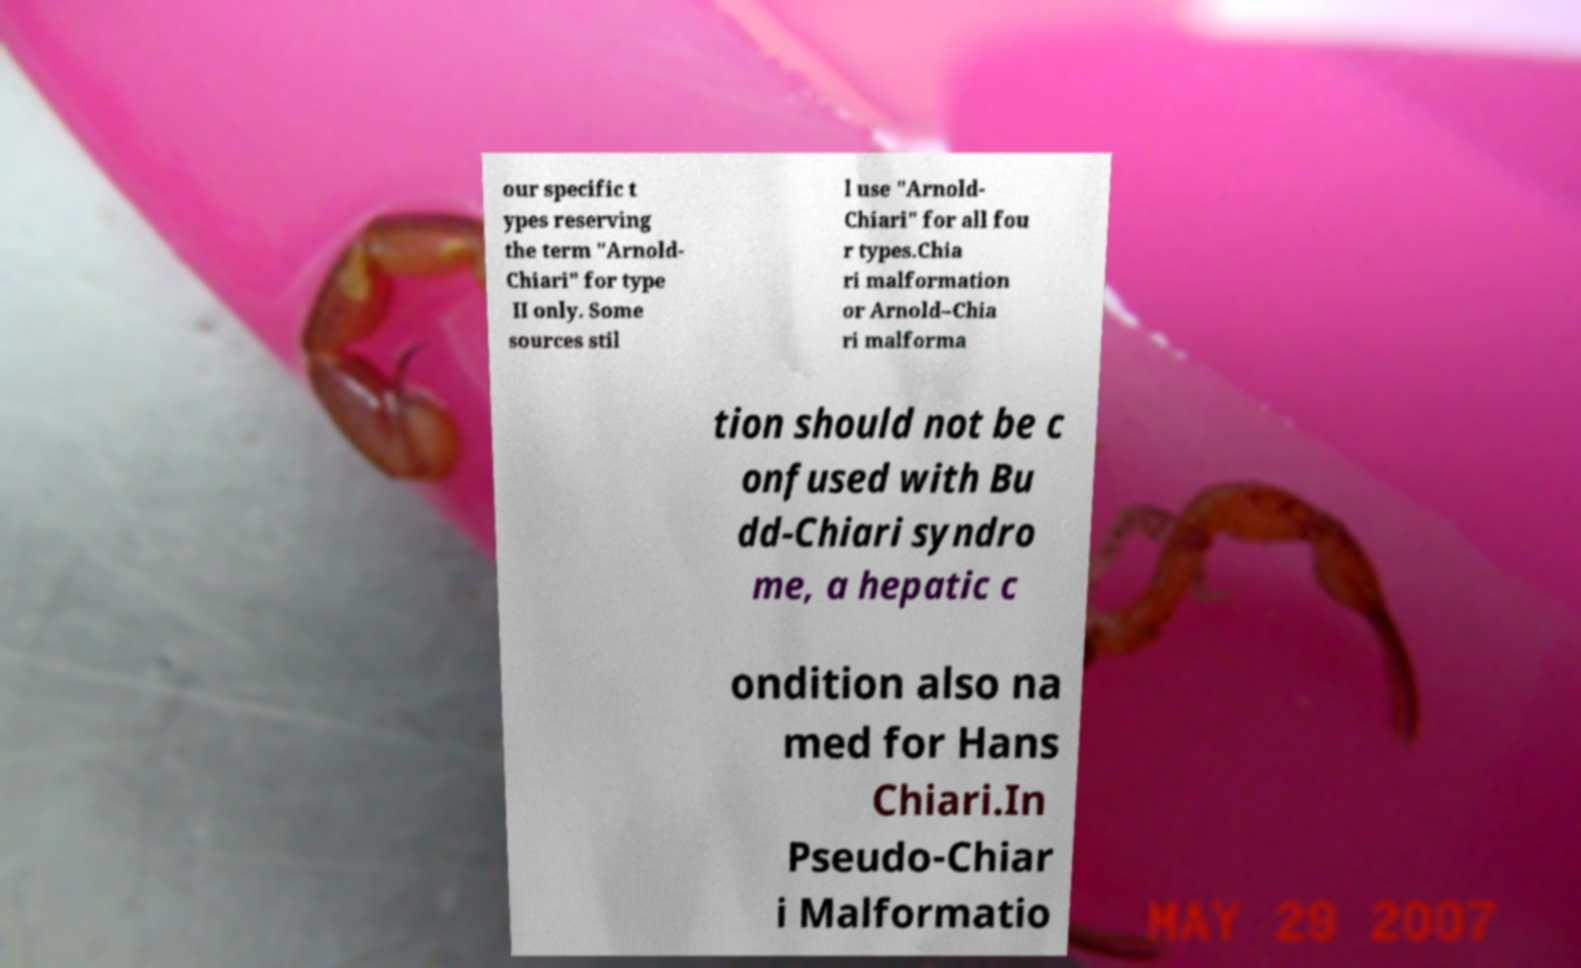Please read and relay the text visible in this image. What does it say? our specific t ypes reserving the term "Arnold- Chiari" for type II only. Some sources stil l use "Arnold- Chiari" for all fou r types.Chia ri malformation or Arnold–Chia ri malforma tion should not be c onfused with Bu dd-Chiari syndro me, a hepatic c ondition also na med for Hans Chiari.In Pseudo-Chiar i Malformatio 